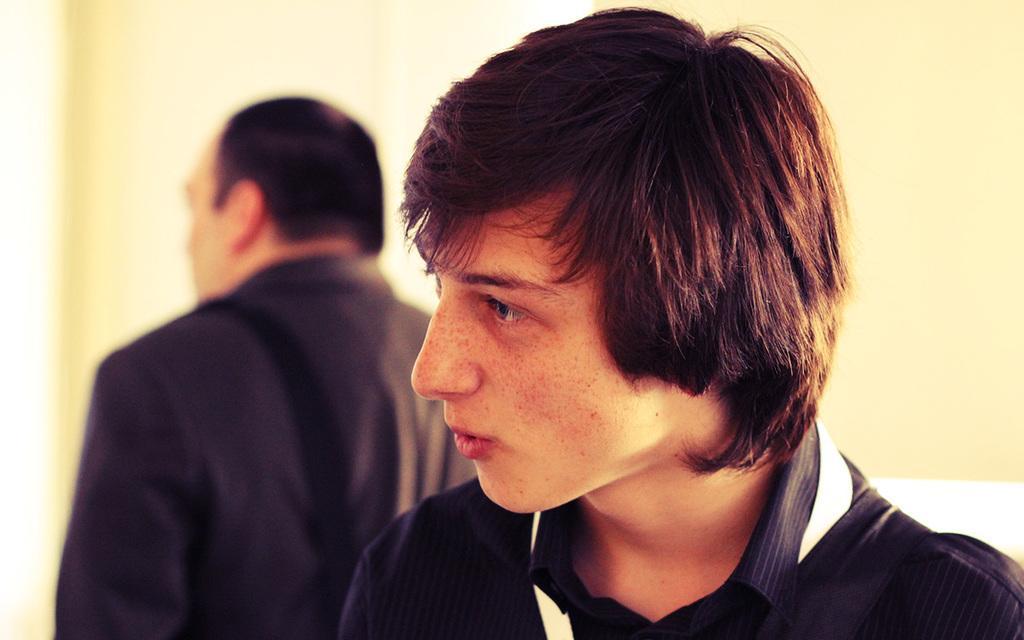How would you summarize this image in a sentence or two? There is a man wearing a black shirt. In the background there is another person. Also there is a wall in the background. 